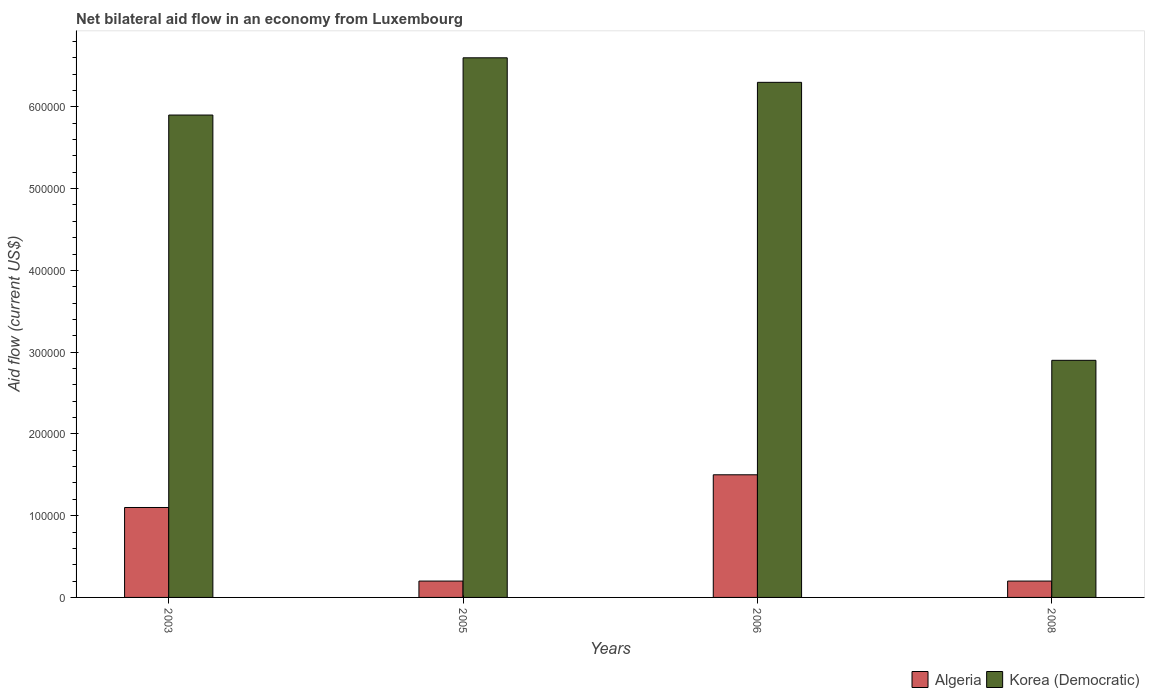What is the label of the 4th group of bars from the left?
Provide a short and direct response. 2008. What is the net bilateral aid flow in Algeria in 2005?
Offer a terse response. 2.00e+04. Across all years, what is the maximum net bilateral aid flow in Algeria?
Offer a terse response. 1.50e+05. What is the total net bilateral aid flow in Korea (Democratic) in the graph?
Your answer should be compact. 2.17e+06. What is the difference between the net bilateral aid flow in Algeria in 2003 and the net bilateral aid flow in Korea (Democratic) in 2006?
Offer a terse response. -5.20e+05. What is the average net bilateral aid flow in Korea (Democratic) per year?
Ensure brevity in your answer.  5.42e+05. What is the ratio of the net bilateral aid flow in Korea (Democratic) in 2006 to that in 2008?
Offer a terse response. 2.17. Is the net bilateral aid flow in Korea (Democratic) in 2006 less than that in 2008?
Your response must be concise. No. What is the difference between the highest and the second highest net bilateral aid flow in Algeria?
Your response must be concise. 4.00e+04. In how many years, is the net bilateral aid flow in Korea (Democratic) greater than the average net bilateral aid flow in Korea (Democratic) taken over all years?
Your answer should be very brief. 3. What does the 2nd bar from the left in 2003 represents?
Offer a terse response. Korea (Democratic). What does the 2nd bar from the right in 2005 represents?
Your answer should be compact. Algeria. How many bars are there?
Your response must be concise. 8. Are all the bars in the graph horizontal?
Make the answer very short. No. How many years are there in the graph?
Keep it short and to the point. 4. What is the difference between two consecutive major ticks on the Y-axis?
Provide a short and direct response. 1.00e+05. Does the graph contain any zero values?
Give a very brief answer. No. Does the graph contain grids?
Offer a terse response. No. How many legend labels are there?
Offer a terse response. 2. How are the legend labels stacked?
Your answer should be compact. Horizontal. What is the title of the graph?
Offer a very short reply. Net bilateral aid flow in an economy from Luxembourg. What is the label or title of the X-axis?
Offer a terse response. Years. What is the Aid flow (current US$) in Korea (Democratic) in 2003?
Your answer should be compact. 5.90e+05. What is the Aid flow (current US$) in Algeria in 2005?
Make the answer very short. 2.00e+04. What is the Aid flow (current US$) of Korea (Democratic) in 2006?
Keep it short and to the point. 6.30e+05. Across all years, what is the maximum Aid flow (current US$) in Algeria?
Your answer should be very brief. 1.50e+05. What is the total Aid flow (current US$) of Korea (Democratic) in the graph?
Your response must be concise. 2.17e+06. What is the difference between the Aid flow (current US$) of Algeria in 2003 and that in 2005?
Your response must be concise. 9.00e+04. What is the difference between the Aid flow (current US$) of Korea (Democratic) in 2005 and that in 2006?
Your answer should be very brief. 3.00e+04. What is the difference between the Aid flow (current US$) of Algeria in 2006 and that in 2008?
Your answer should be very brief. 1.30e+05. What is the difference between the Aid flow (current US$) of Algeria in 2003 and the Aid flow (current US$) of Korea (Democratic) in 2005?
Give a very brief answer. -5.50e+05. What is the difference between the Aid flow (current US$) of Algeria in 2003 and the Aid flow (current US$) of Korea (Democratic) in 2006?
Provide a short and direct response. -5.20e+05. What is the difference between the Aid flow (current US$) of Algeria in 2003 and the Aid flow (current US$) of Korea (Democratic) in 2008?
Offer a very short reply. -1.80e+05. What is the difference between the Aid flow (current US$) in Algeria in 2005 and the Aid flow (current US$) in Korea (Democratic) in 2006?
Your response must be concise. -6.10e+05. What is the difference between the Aid flow (current US$) of Algeria in 2005 and the Aid flow (current US$) of Korea (Democratic) in 2008?
Your answer should be compact. -2.70e+05. What is the average Aid flow (current US$) of Algeria per year?
Provide a succinct answer. 7.50e+04. What is the average Aid flow (current US$) of Korea (Democratic) per year?
Offer a terse response. 5.42e+05. In the year 2003, what is the difference between the Aid flow (current US$) in Algeria and Aid flow (current US$) in Korea (Democratic)?
Provide a succinct answer. -4.80e+05. In the year 2005, what is the difference between the Aid flow (current US$) of Algeria and Aid flow (current US$) of Korea (Democratic)?
Make the answer very short. -6.40e+05. In the year 2006, what is the difference between the Aid flow (current US$) of Algeria and Aid flow (current US$) of Korea (Democratic)?
Make the answer very short. -4.80e+05. What is the ratio of the Aid flow (current US$) in Korea (Democratic) in 2003 to that in 2005?
Offer a terse response. 0.89. What is the ratio of the Aid flow (current US$) of Algeria in 2003 to that in 2006?
Make the answer very short. 0.73. What is the ratio of the Aid flow (current US$) of Korea (Democratic) in 2003 to that in 2006?
Offer a terse response. 0.94. What is the ratio of the Aid flow (current US$) of Korea (Democratic) in 2003 to that in 2008?
Your answer should be very brief. 2.03. What is the ratio of the Aid flow (current US$) in Algeria in 2005 to that in 2006?
Make the answer very short. 0.13. What is the ratio of the Aid flow (current US$) in Korea (Democratic) in 2005 to that in 2006?
Provide a short and direct response. 1.05. What is the ratio of the Aid flow (current US$) of Korea (Democratic) in 2005 to that in 2008?
Your response must be concise. 2.28. What is the ratio of the Aid flow (current US$) of Korea (Democratic) in 2006 to that in 2008?
Make the answer very short. 2.17. 